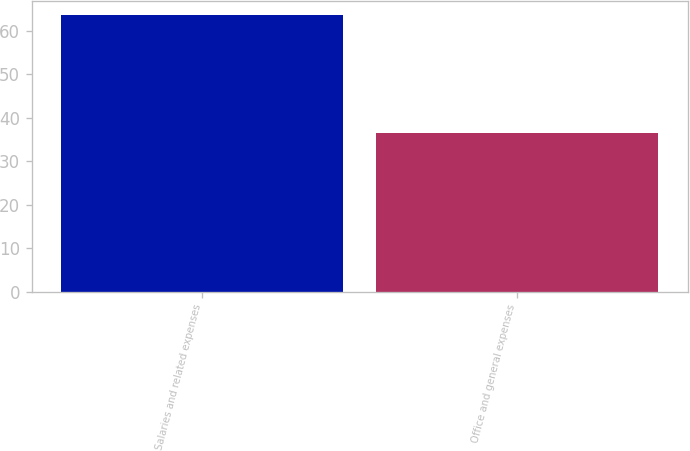<chart> <loc_0><loc_0><loc_500><loc_500><bar_chart><fcel>Salaries and related expenses<fcel>Office and general expenses<nl><fcel>63.7<fcel>36.5<nl></chart> 